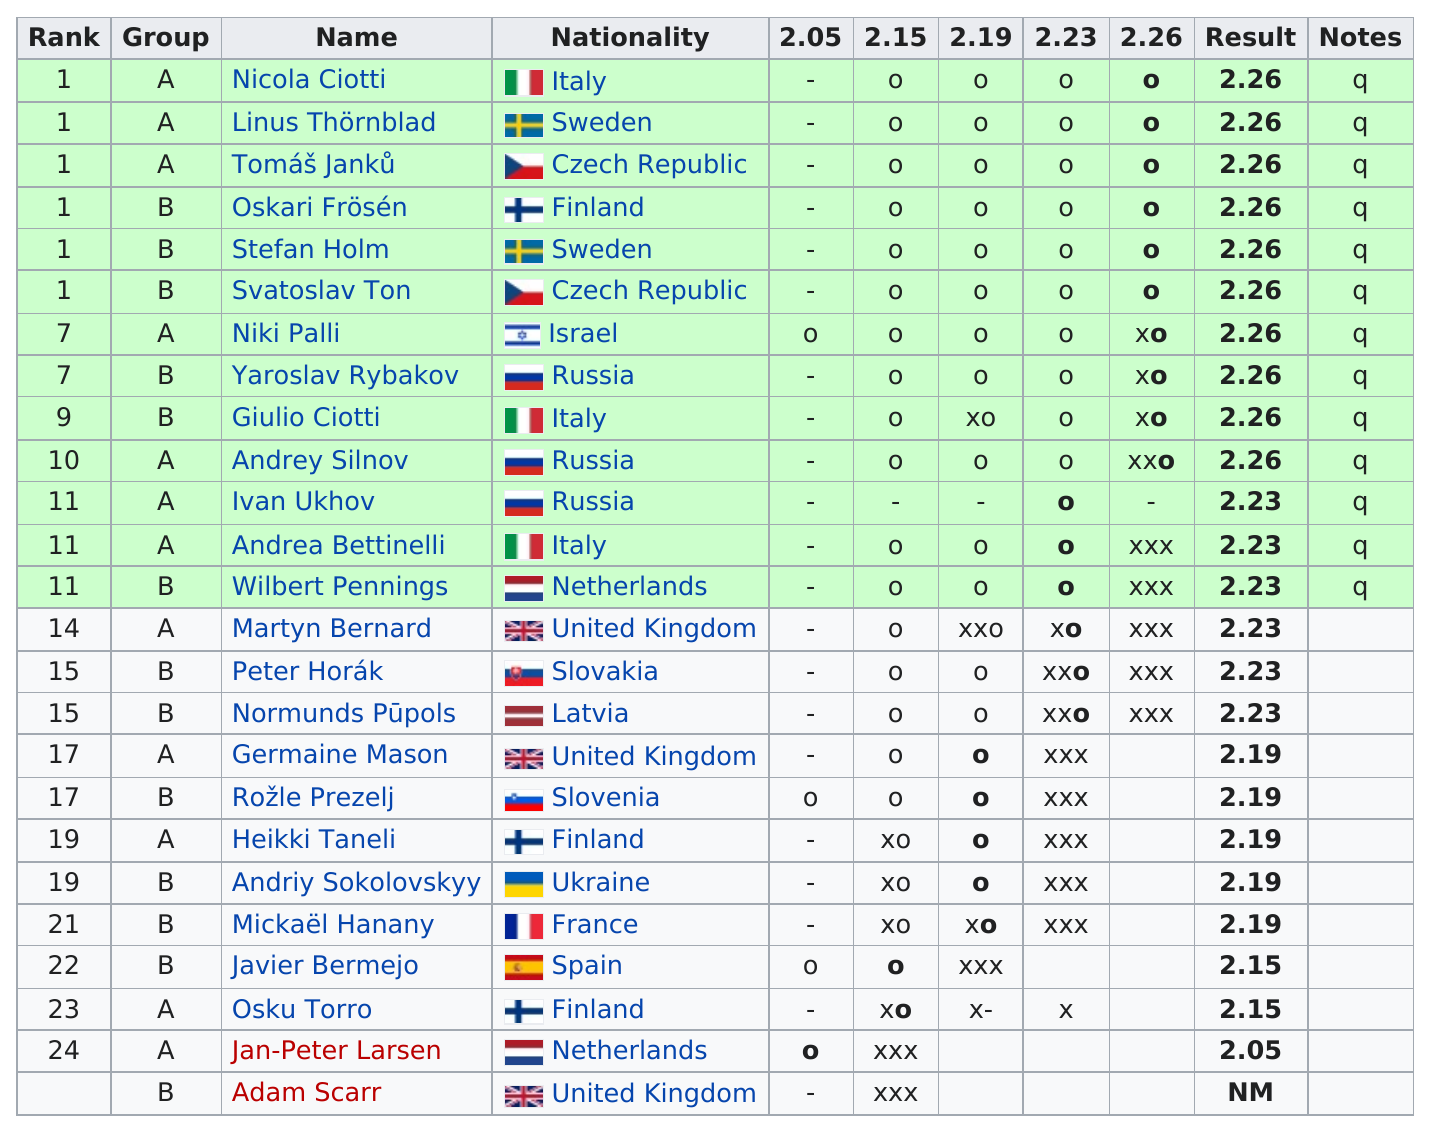Outline some significant characteristics in this image. The following individuals are not part of group A: Oskari Frösén, Stefan Holm, Svatoslav Ton, Yaroslav Rybakov, Giulio Ciotti, Wilbert Pennings, Peter Horák, Normunds Pūpols, Rožle Prezelj, Andriy Sokolovskyy, Mickaël Hanany, Javier Bermejo, and Adam Scarr. Jan-Peter Larsen is the only high jumper to have achieved a result of 2.05 in his/her career. There were five high jumpers who achieved a result of 2.19. The nationality of the performer listed before Niki Palli is Czech Republic. Yaroslav Rybakov's name is listed below Niki Palli. 